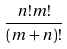<formula> <loc_0><loc_0><loc_500><loc_500>\frac { n ! m ! } { ( m + n ) ! }</formula> 